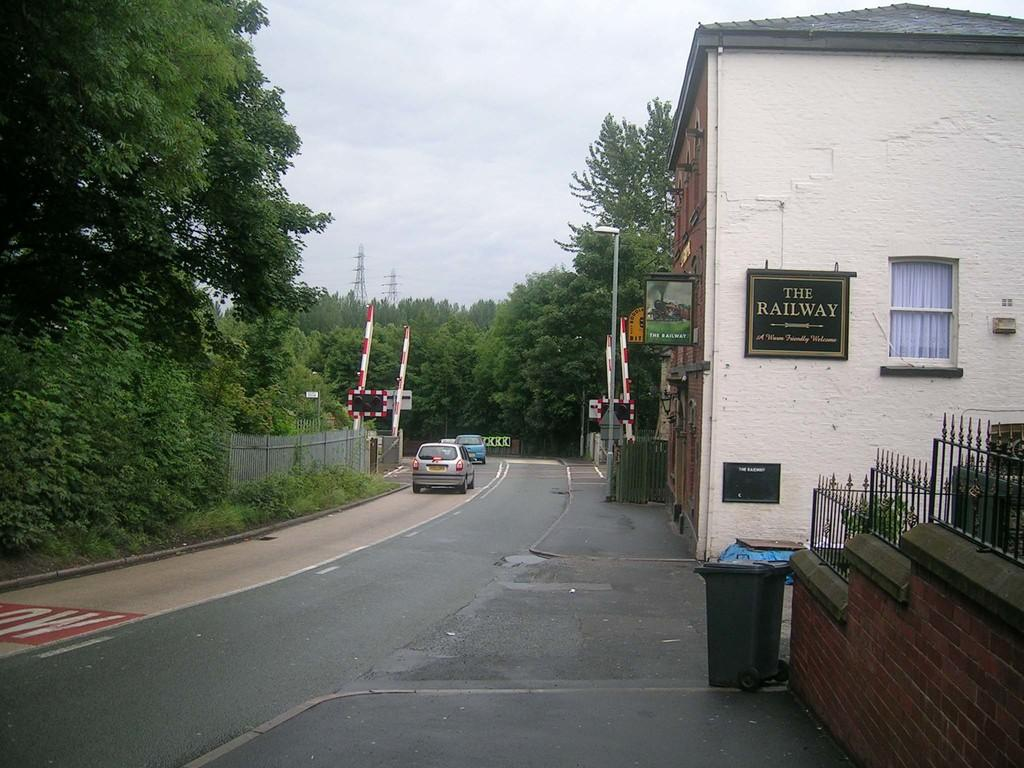<image>
Render a clear and concise summary of the photo. A sign for The Railway hangs on the side of a small building on a quiet street. 